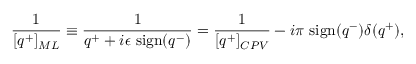<formula> <loc_0><loc_0><loc_500><loc_500>{ \frac { 1 } { [ q ^ { + } ] _ { M L } } } \equiv \frac { 1 } { q ^ { + } + i \epsilon \ s i g n ( q ^ { - } ) } = { \frac { 1 } { [ q ^ { + } ] _ { C P V } } } - i \pi \ s i g n ( q ^ { - } ) \delta ( q ^ { + } ) ,</formula> 